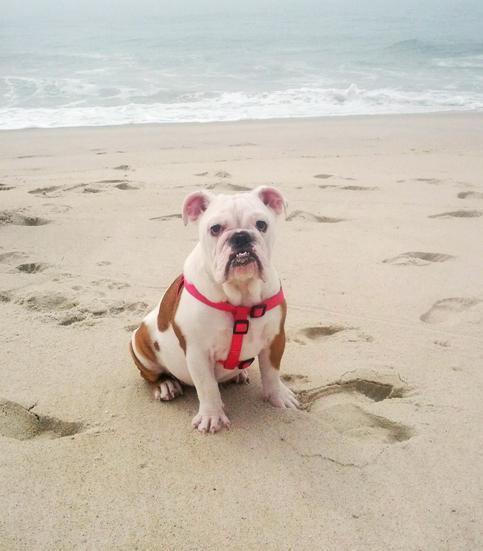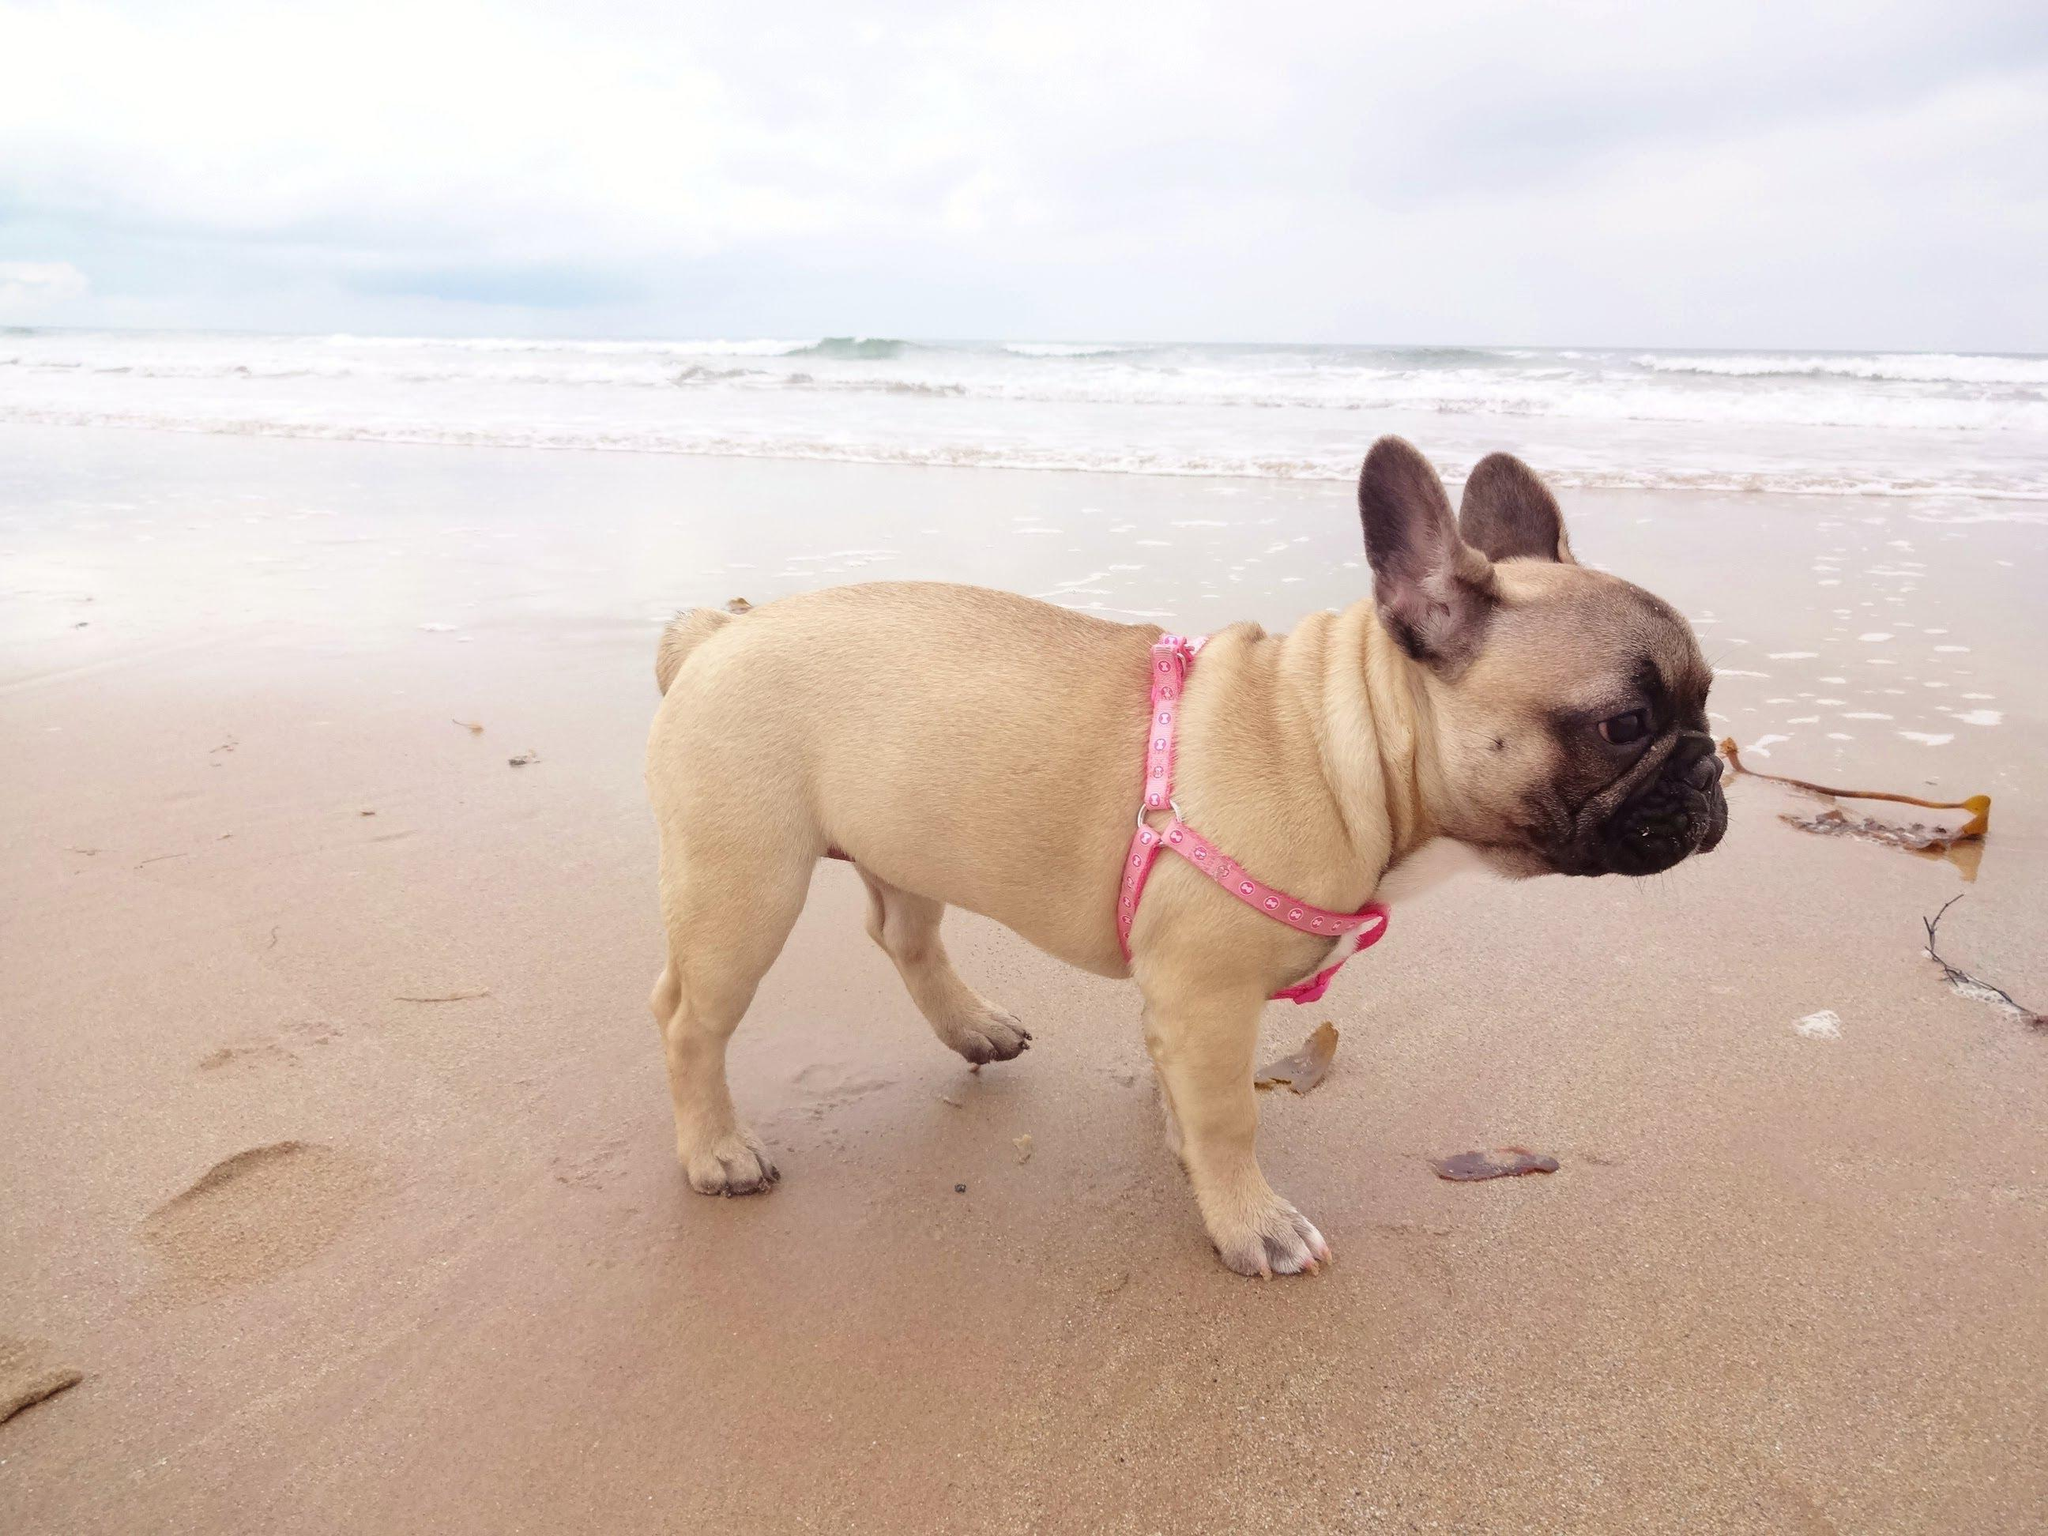The first image is the image on the left, the second image is the image on the right. Given the left and right images, does the statement "An image shows a brownish dog in profile, wearing a harness." hold true? Answer yes or no. Yes. 